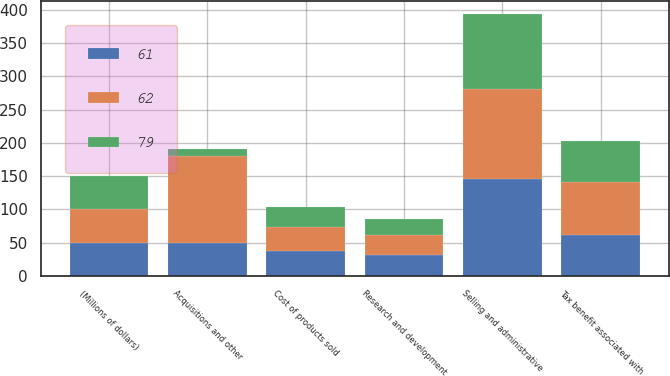Convert chart to OTSL. <chart><loc_0><loc_0><loc_500><loc_500><stacked_bar_chart><ecel><fcel>(Millions of dollars)<fcel>Cost of products sold<fcel>Selling and administrative<fcel>Research and development<fcel>Acquisitions and other<fcel>Tax benefit associated with<nl><fcel>61<fcel>50<fcel>37<fcel>145<fcel>32<fcel>50<fcel>62<nl><fcel>62<fcel>50<fcel>36<fcel>136<fcel>29<fcel>130<fcel>79<nl><fcel>79<fcel>50<fcel>30<fcel>113<fcel>24<fcel>10<fcel>61<nl></chart> 